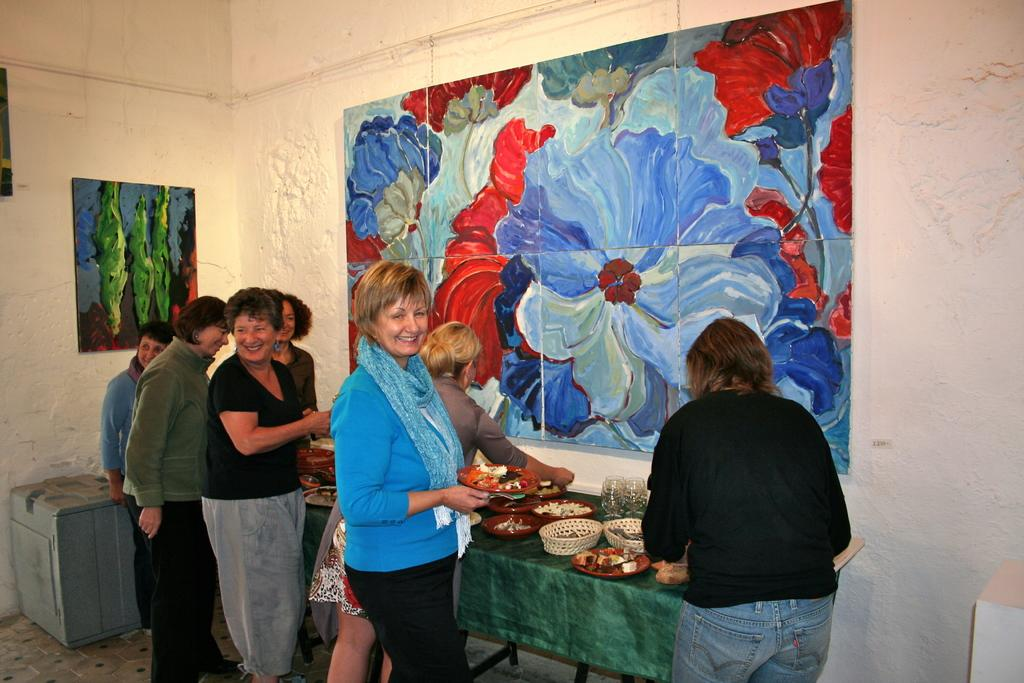What can be seen on the wall in the image? There are paintings on the wall in the image. What is on the table in the image? There is a table with food in the image. Can you describe the people in the image? There is a group of people standing near the table in the image. What month is depicted in the paintings on the wall? The provided facts do not mention any specific month depicted in the paintings, so we cannot answer this question. What type of creature is present in the image? There is no creature present in the image; it features paintings, a table with food, and a group of people. 